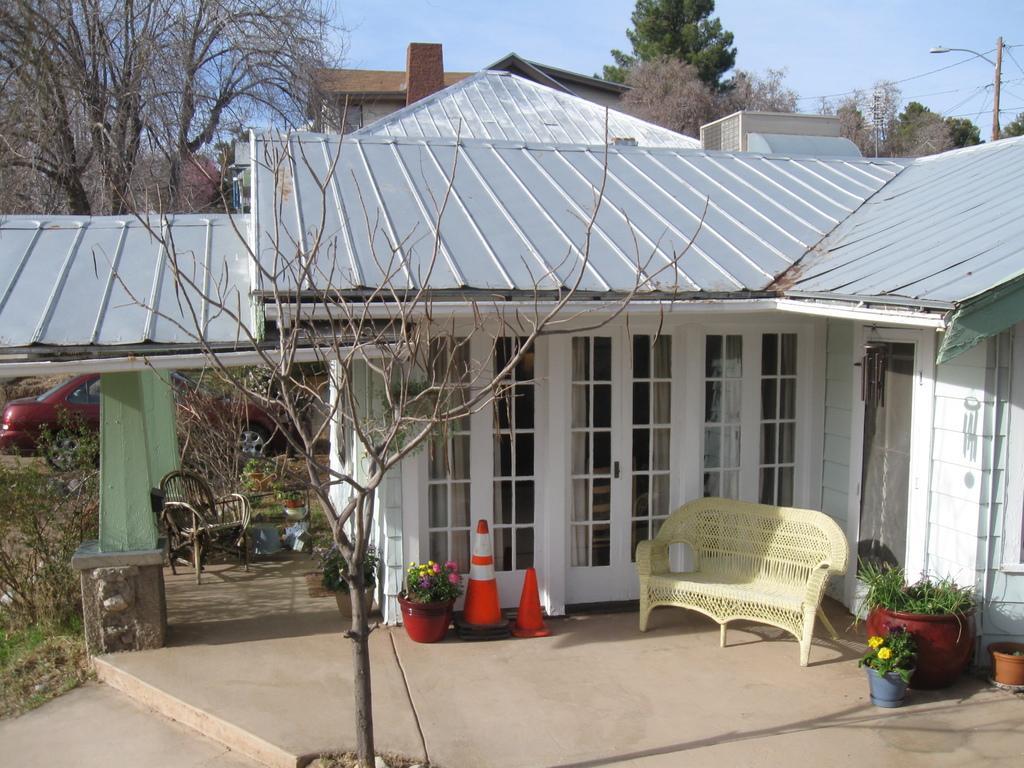Can you describe this image briefly? In this image I can see the house. In front of the house there is a couch,flower pots and the traffic cones. I can also see the car. There are some plants and the sky. 